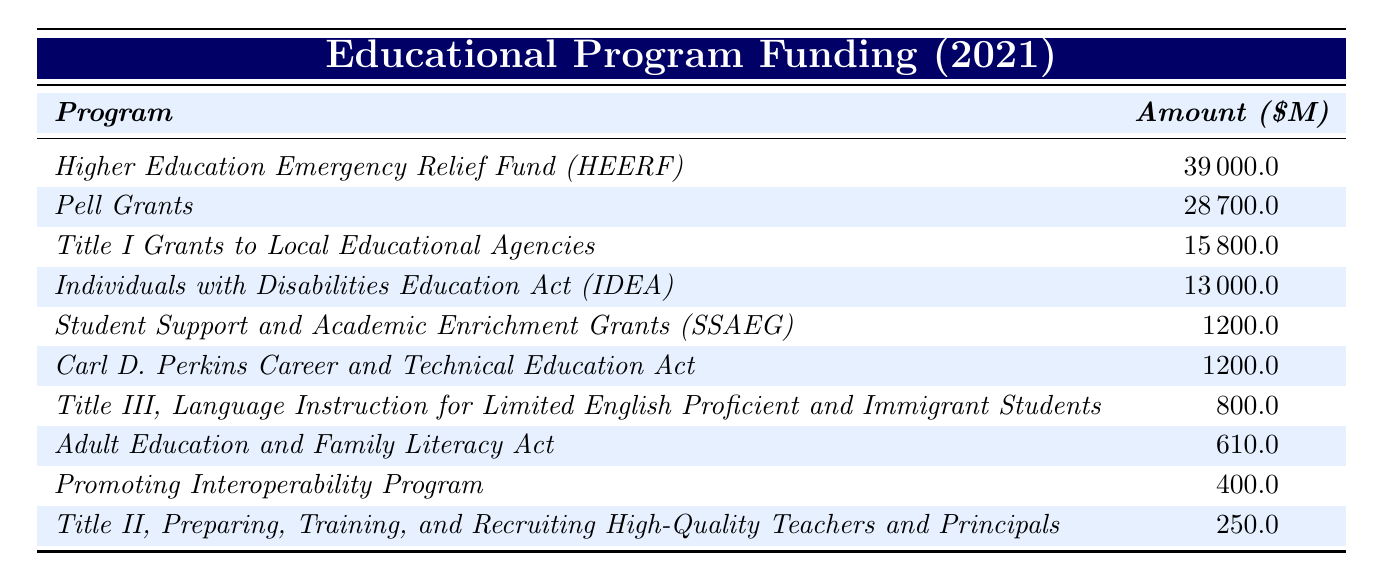What is the total funding allocated to Pell Grants? The table shows that the amount allocated to Pell Grants is 28,700 million dollars. Thus, the total funding for Pell Grants is directly listed in the table.
Answer: 28,700 million dollars Which program received the highest amount of funding? The table lists the funding amounts for each program. The program with the highest funding is the Higher Education Emergency Relief Fund (HEERF) with 39,000 million dollars.
Answer: Higher Education Emergency Relief Fund (HEERF) How much was allocated to Title II, Preparing, Training, and Recruiting High-Quality Teachers and Principals? According to the table, the amount allocated to Title II is 250 million dollars. This information is stated clearly in the table.
Answer: 250 million dollars What is the total funding amount allocated to career-focused education programs (Carl D. Perkins and Adult Education)? For career-focused education programs, the table shows 1,200 million dollars for the Carl D. Perkins Career and Technical Education Act and 610 million dollars for the Adult Education and Family Literacy Act. Adding these amounts gives 1,200 + 610 = 1,810 million dollars.
Answer: 1,810 million dollars Is the funding allocated to Student Support and Academic Enrichment Grants (SSAEG) more than that for Title III? Reviewing the table, the funding for SSAEG is 1,200 million dollars and for Title III is 800 million dollars. Since 1,200 is greater than 800, the statement is true.
Answer: Yes What is the average funding allocated among all the listed programs? The table lists 10 programs with their respective funding amounts. First, sum up all the funding amounts: 39,000 + 28,700 + 15,800 + 13,000 + 1,200 + 1,200 + 610 + 800 + 400 + 250 = 100,160 million dollars. To find the average, divide the total by the number of programs: 100,160 / 10 = 10,016 million dollars.
Answer: 10,016 million dollars Which two programs together received over 30,000 million dollars? From the table, the Higher Education Emergency Relief Fund (HEERF) received 39,000 million dollars and Pell Grants received 28,700 million dollars. However, individually, Pell Grants is the only one exceeding 30,000 million, while HEERF alone exceeds it. Therefore, only HEERF qualifies.
Answer: Higher Education Emergency Relief Fund (HEERF) alone What percentage of the total funding is allocated to Title I Grants to Local Educational Agencies? From the previous question, the total funding is 100,160 million dollars, and Title I Grants received 15,800 million dollars. To calculate the percentage, use the formula (15,800 / 100,160) * 100 = approximately 15.8%.
Answer: 15.8% 